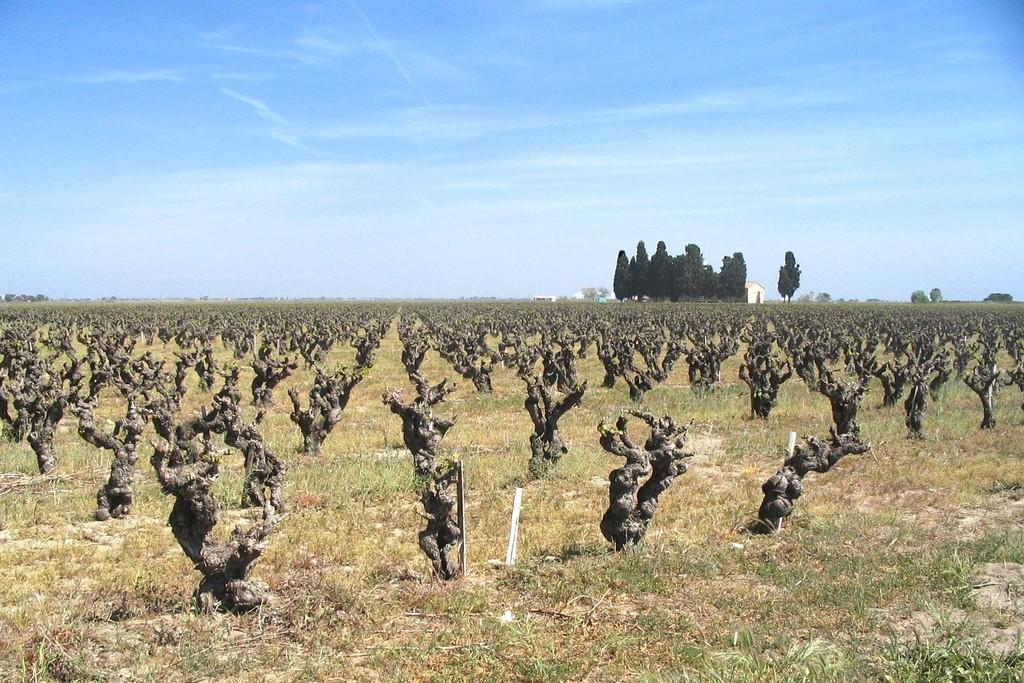What type of vegetation can be seen in the image? There is grass in the image. What else can be seen in the image besides grass? There are trees in the image. What type of structure is present in the image? There is a house in the image. What is visible in the background of the image? The sky is visible in the background of the image. What type of memory is being taught in the class shown in the image? There is no class or memory being taught in the image; it features grass, trees, a house, and the sky. Can you tell me how many airplanes are flying in the sky in the image? There are no airplanes visible in the sky in the image. 